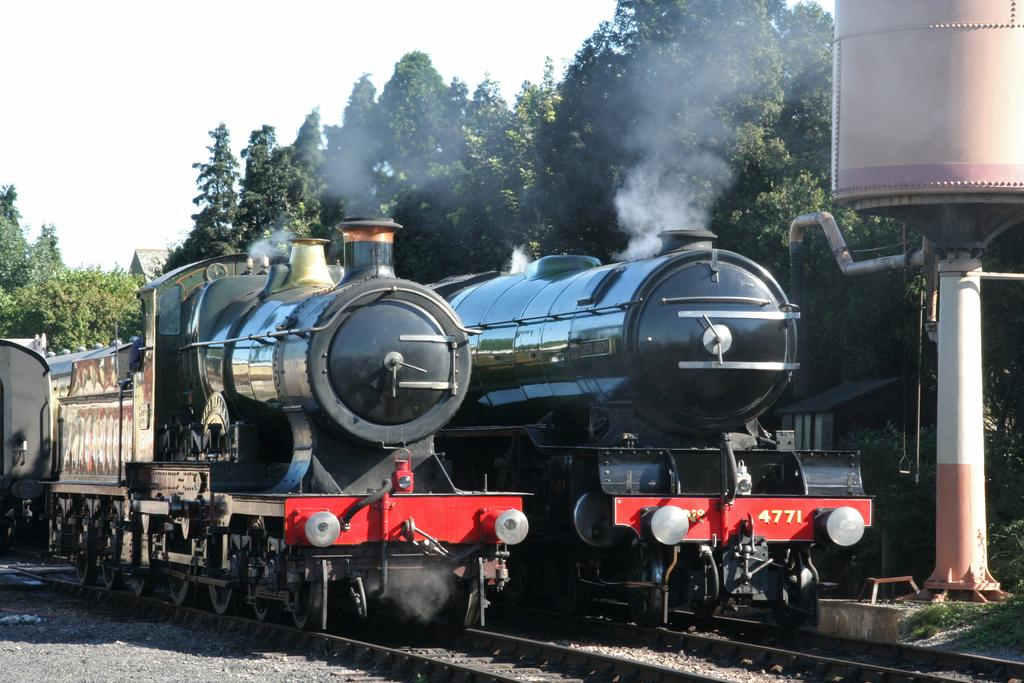What type of vehicles can be seen in the image? There are trains in the image. What is the path that the trains are following? Railway tracks are visible in the image. What is the large object near the trains? A container is present in the image. What type of natural environment is visible in the image? There is grass visible in the image. What is visible in the sky in the image? The sky is visible in the image. What type of vegetation is present in the image? There are trees in the image. What type of paper is the achiever holding in the image? There is no achiever or paper present in the image; it features trains, railway tracks, a container, grass, the sky, and trees. 